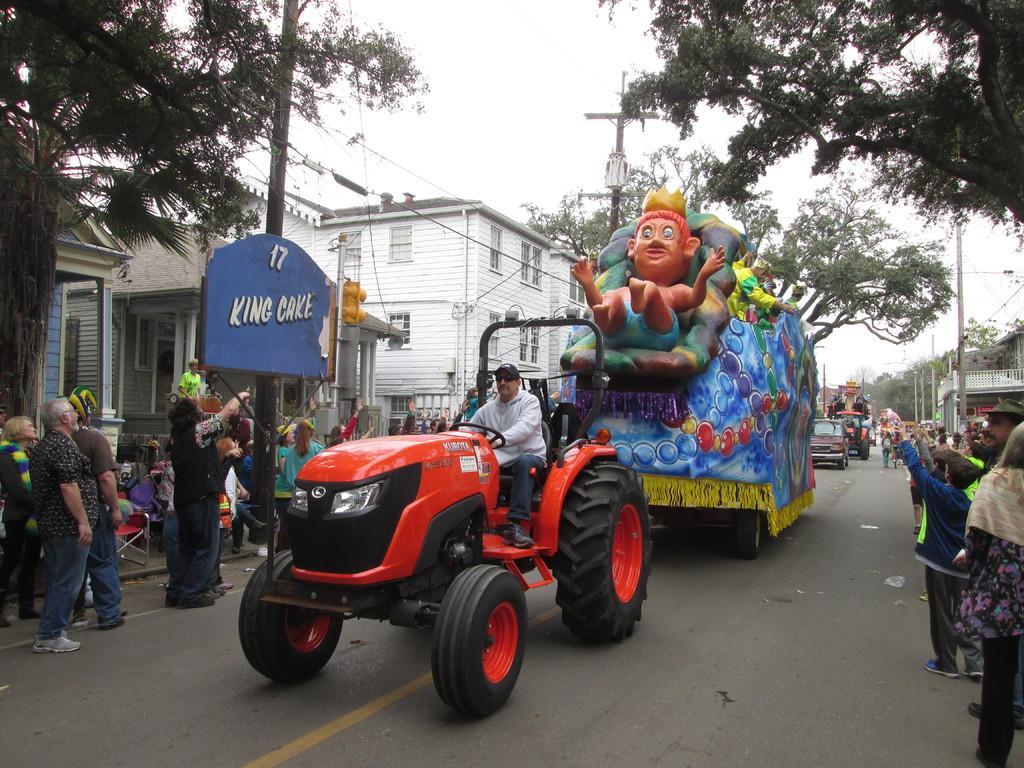In one or two sentences, can you explain what this image depicts? In the foreground of this image, there is a tractor and few more vehicles moving on the road. On either side, there are people standing holding few objects, trees, buildings, poles and cables. On the left, there is a broad. At the top, there is the sky. 